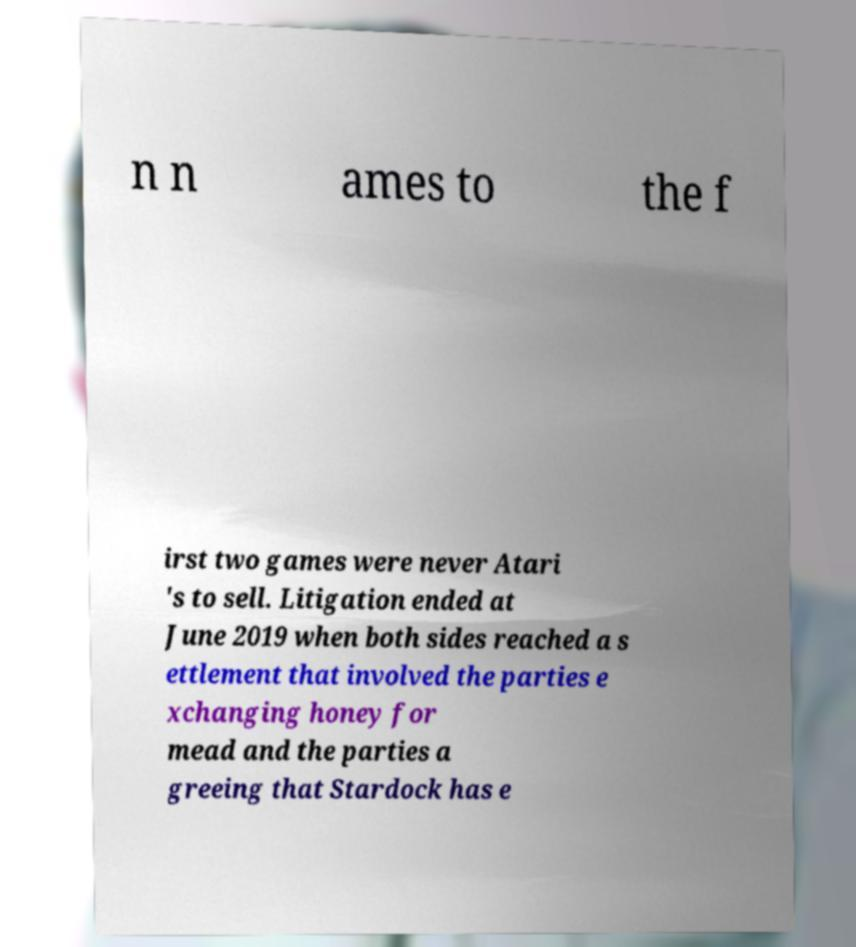Could you extract and type out the text from this image? n n ames to the f irst two games were never Atari 's to sell. Litigation ended at June 2019 when both sides reached a s ettlement that involved the parties e xchanging honey for mead and the parties a greeing that Stardock has e 